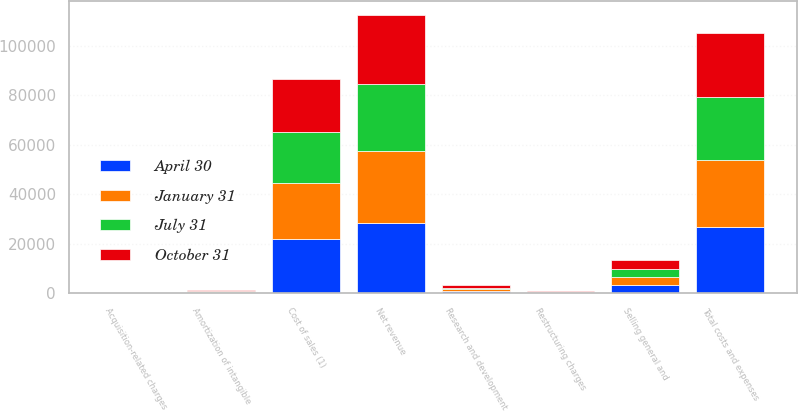Convert chart to OTSL. <chart><loc_0><loc_0><loc_500><loc_500><stacked_bar_chart><ecel><fcel>Net revenue<fcel>Cost of sales (1)<fcel>Research and development<fcel>Selling general and<fcel>Amortization of intangible<fcel>Restructuring charges<fcel>Acquisition-related charges<fcel>Total costs and expenses<nl><fcel>April 30<fcel>28359<fcel>22029<fcel>794<fcel>3300<fcel>350<fcel>130<fcel>4<fcel>26607<nl><fcel>October 31<fcel>27582<fcel>21055<fcel>815<fcel>3342<fcel>350<fcel>408<fcel>11<fcel>25981<nl><fcel>July 31<fcel>27226<fcel>20859<fcel>797<fcel>3274<fcel>356<fcel>81<fcel>4<fcel>25371<nl><fcel>January 31<fcel>29131<fcel>22437<fcel>729<fcel>3351<fcel>317<fcel>371<fcel>3<fcel>27208<nl></chart> 